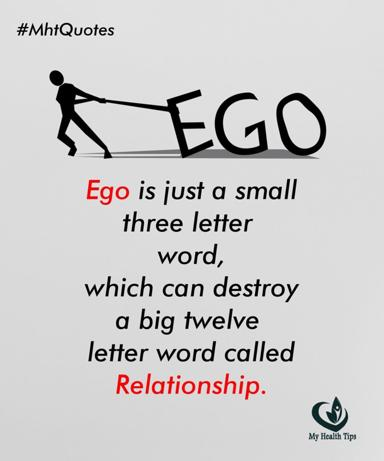What is the quote about ego and relationship in the image?
 The quote in the image is "Ego is just a small three letter word, which can destroy a big twelve letter word called Relationship." This is from My Health Tips. How can ego affect relationships according to the quote? The quote suggests that ego, despite being a small concept represented by a three-letter word, has the power to negatively impact and even destroy relationships, which is a more complex and significant concept represented by a twelve-letter word. This highlights the potential harm that ego can cause in interpersonal connections and reinforces the importance of managing one's ego to maintain healthy relationships. 